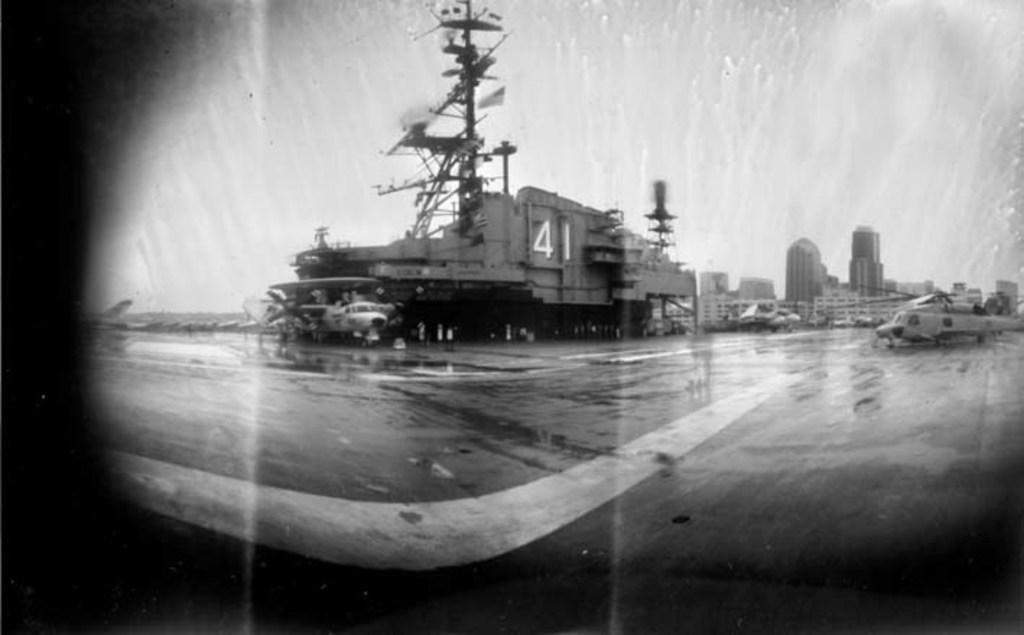What type of vehicles can be seen in the image? There are air crafts in the image. What structures are present in the image? There are buildings and towers in the image. What part of the natural environment is visible in the image? The sky is visible in the image. What is the color scheme of the image? The image is in black and white mode. What type of sweater is being worn by the committee in the field in the image? There is no committee, field, or sweater present in the image. 